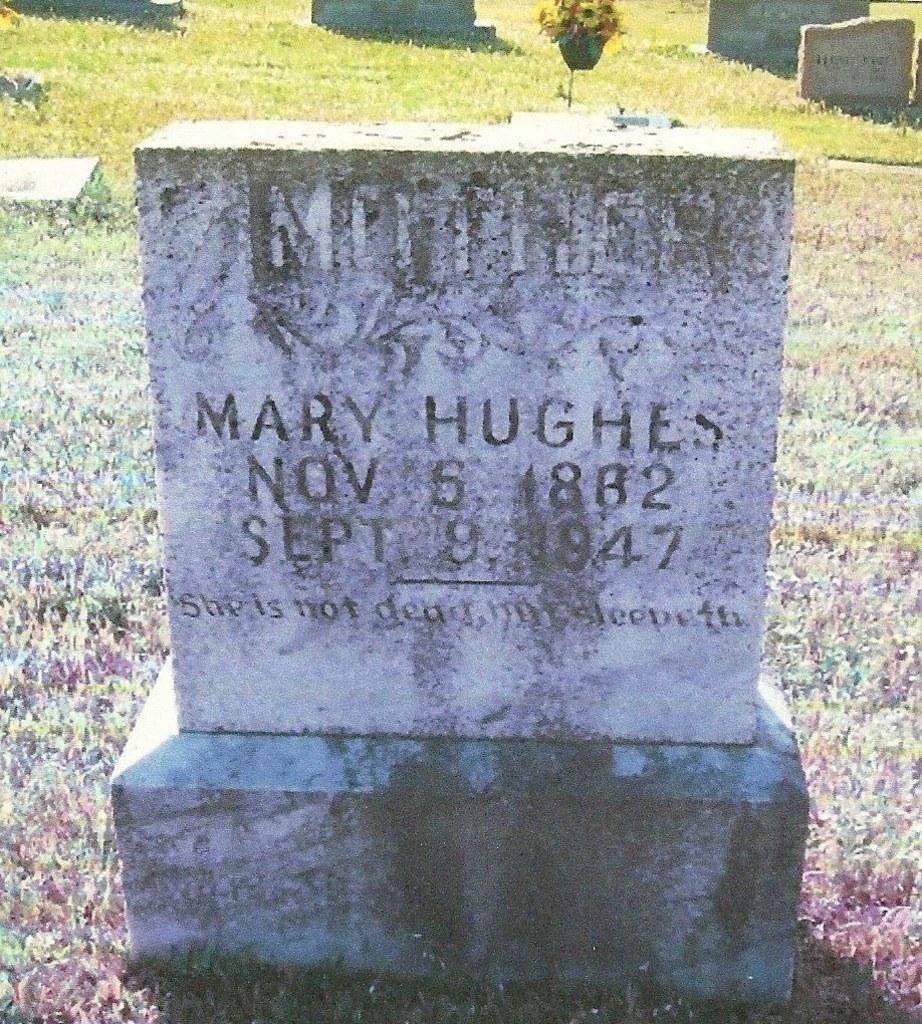Please provide a concise description of this image. In this picture we can see a headstone on the path and behind the headstone there are some other headstones. 